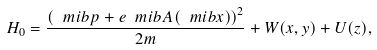Convert formula to latex. <formula><loc_0><loc_0><loc_500><loc_500>H _ { 0 } = \frac { \left ( \ m i b { p } + e \ m i b { A } ( \ m i b { x } ) \right ) ^ { 2 } } { 2 m } + W ( x , y ) + U ( z ) ,</formula> 